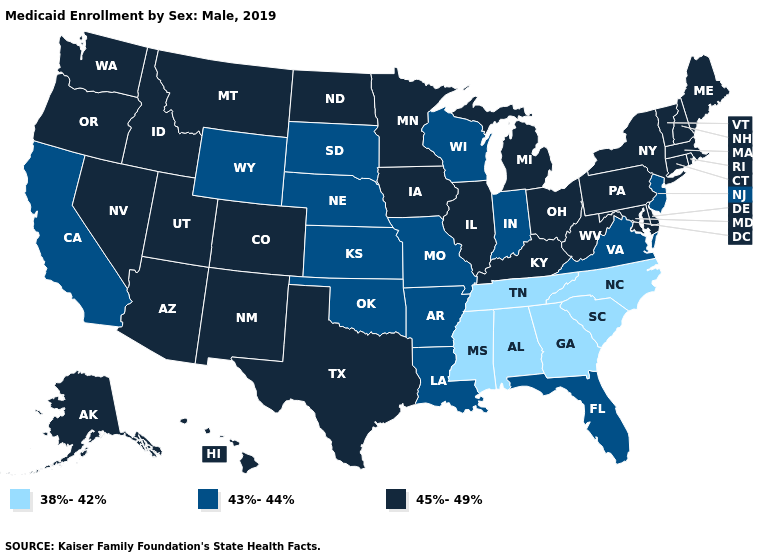What is the lowest value in the USA?
Give a very brief answer. 38%-42%. Does the first symbol in the legend represent the smallest category?
Give a very brief answer. Yes. Does Alaska have a higher value than West Virginia?
Write a very short answer. No. What is the highest value in the USA?
Keep it brief. 45%-49%. Does Florida have a lower value than Ohio?
Write a very short answer. Yes. Does Hawaii have the lowest value in the West?
Quick response, please. No. Among the states that border Maine , which have the lowest value?
Quick response, please. New Hampshire. What is the lowest value in states that border Texas?
Quick response, please. 43%-44%. What is the value of Mississippi?
Give a very brief answer. 38%-42%. Name the states that have a value in the range 43%-44%?
Answer briefly. Arkansas, California, Florida, Indiana, Kansas, Louisiana, Missouri, Nebraska, New Jersey, Oklahoma, South Dakota, Virginia, Wisconsin, Wyoming. What is the value of California?
Short answer required. 43%-44%. Name the states that have a value in the range 45%-49%?
Quick response, please. Alaska, Arizona, Colorado, Connecticut, Delaware, Hawaii, Idaho, Illinois, Iowa, Kentucky, Maine, Maryland, Massachusetts, Michigan, Minnesota, Montana, Nevada, New Hampshire, New Mexico, New York, North Dakota, Ohio, Oregon, Pennsylvania, Rhode Island, Texas, Utah, Vermont, Washington, West Virginia. Does Utah have a lower value than Virginia?
Quick response, please. No. 